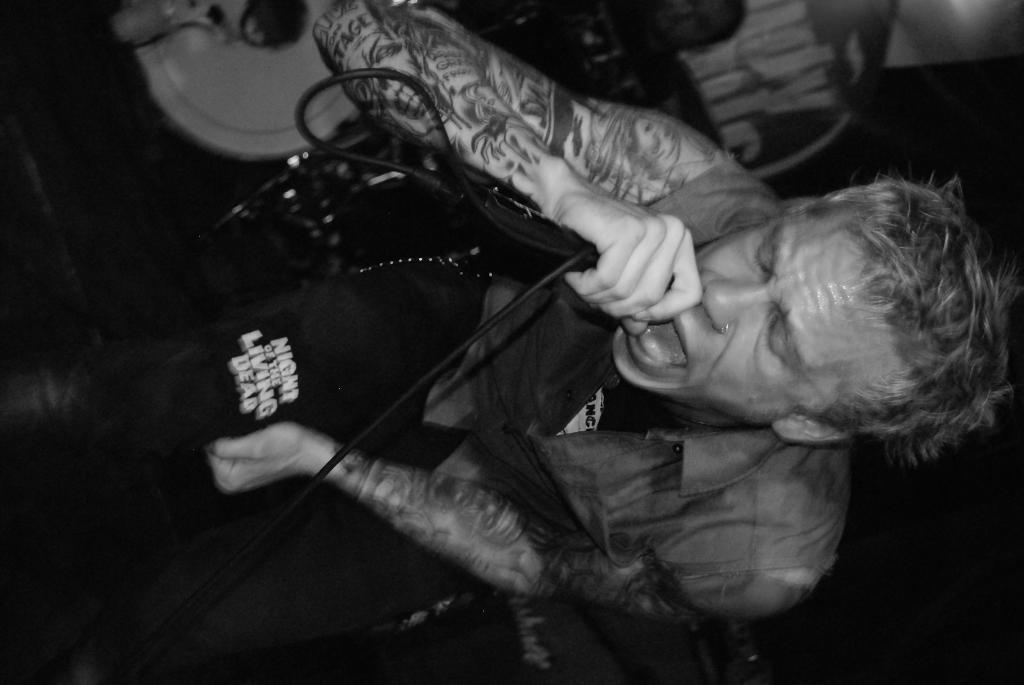What is the main subject of the image? There is a person in the image. What is the person holding in the image? The person is holding something. Can you describe the objects around the person? There are objects around the person. What can be observed about the person's appearance? The person has tattoos on their hands. What is the color scheme of the image? The image is in black and white. What type of string is being used to set up the tent in the image? There is no string or tent present in the image; it features a person holding something with tattoos on their hands. What kind of shock can be seen affecting the person in the image? There is no shock or any indication of a shock in the image; it only shows a person with tattoos on their hands. 